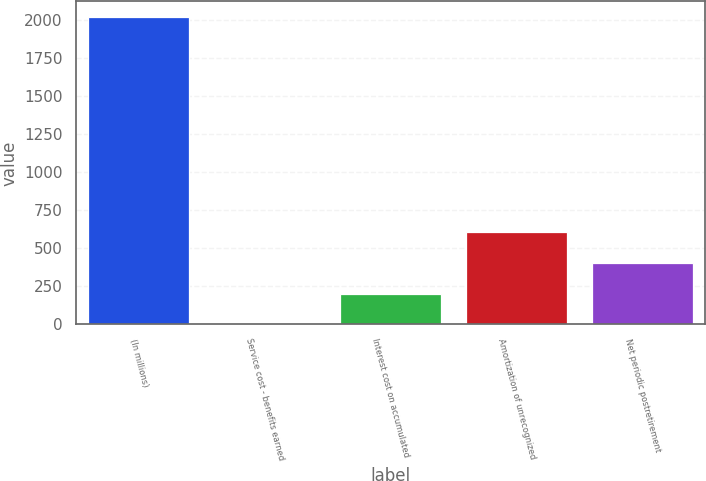Convert chart to OTSL. <chart><loc_0><loc_0><loc_500><loc_500><bar_chart><fcel>(In millions)<fcel>Service cost - benefits earned<fcel>Interest cost on accumulated<fcel>Amortization of unrecognized<fcel>Net periodic postretirement<nl><fcel>2019<fcel>1<fcel>202.8<fcel>606.4<fcel>404.6<nl></chart> 